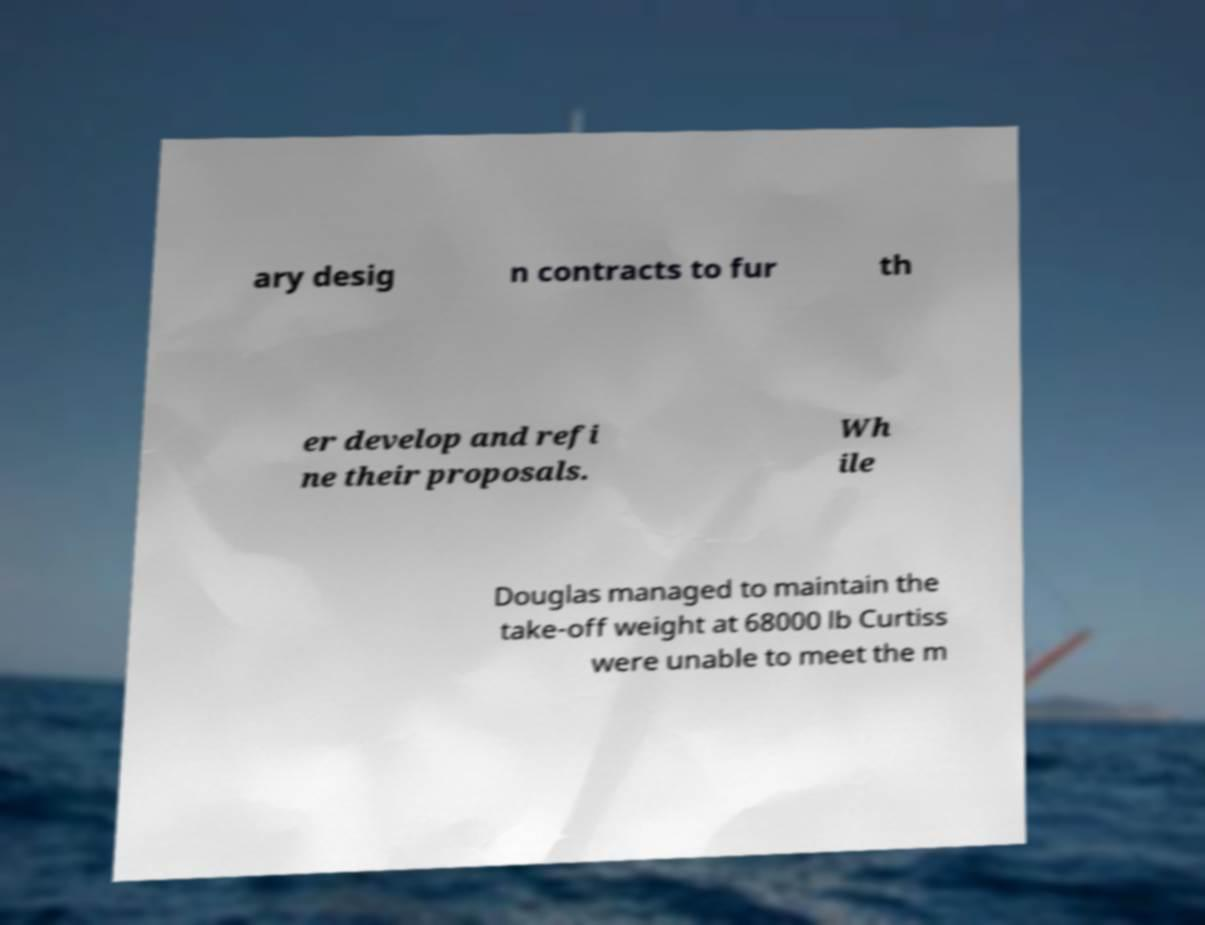Could you assist in decoding the text presented in this image and type it out clearly? ary desig n contracts to fur th er develop and refi ne their proposals. Wh ile Douglas managed to maintain the take-off weight at 68000 lb Curtiss were unable to meet the m 